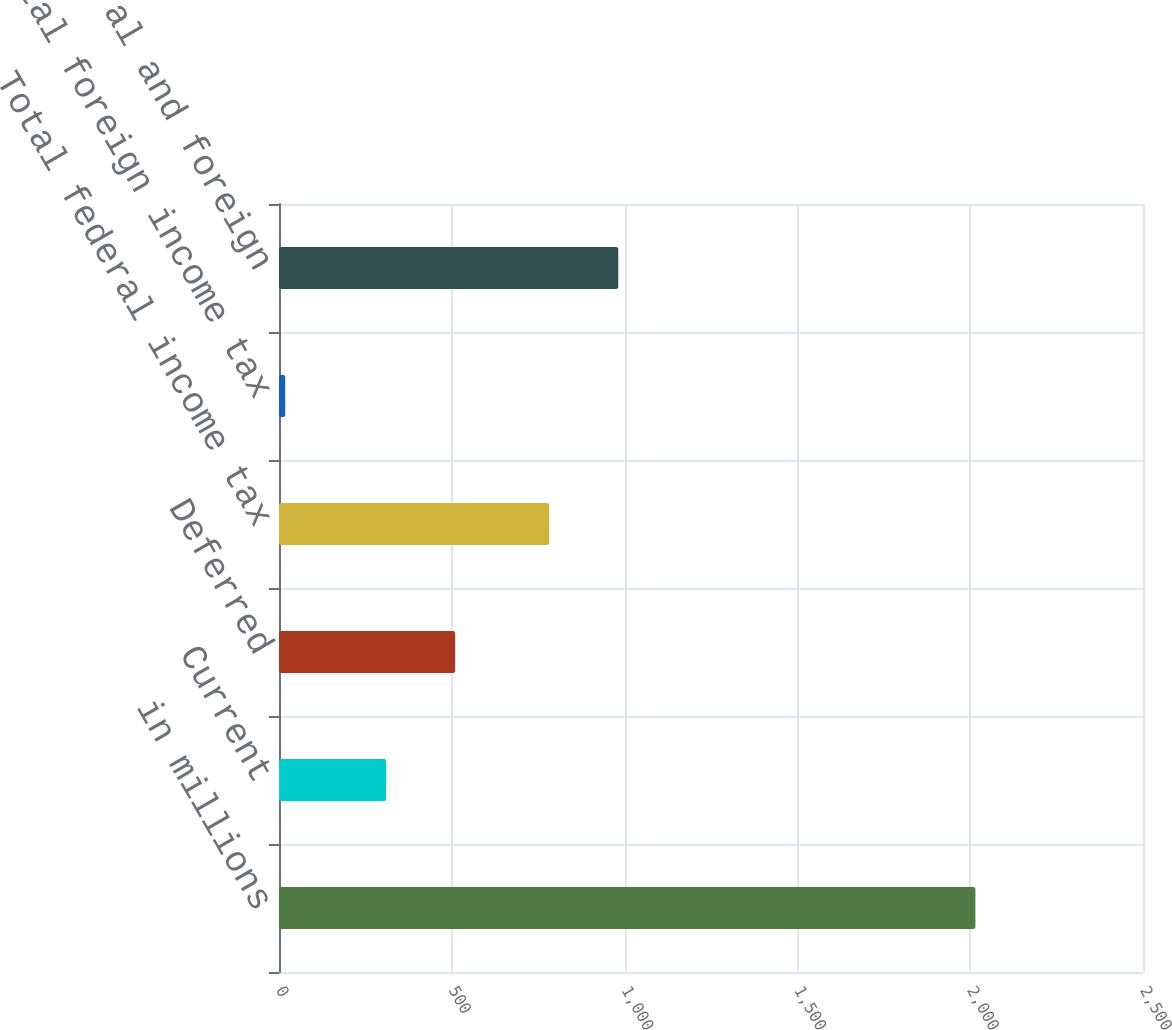Convert chart to OTSL. <chart><loc_0><loc_0><loc_500><loc_500><bar_chart><fcel>in millions<fcel>Current<fcel>Deferred<fcel>Total federal income tax<fcel>Total foreign income tax<fcel>Total federal and foreign<nl><fcel>2015<fcel>310<fcel>509.7<fcel>782<fcel>18<fcel>981.7<nl></chart> 